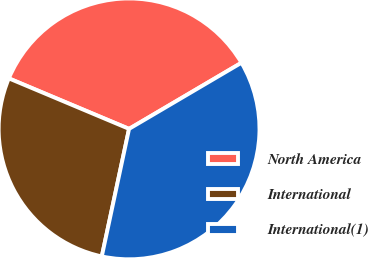Convert chart to OTSL. <chart><loc_0><loc_0><loc_500><loc_500><pie_chart><fcel>North America<fcel>International<fcel>International(1)<nl><fcel>35.21%<fcel>27.98%<fcel>36.82%<nl></chart> 